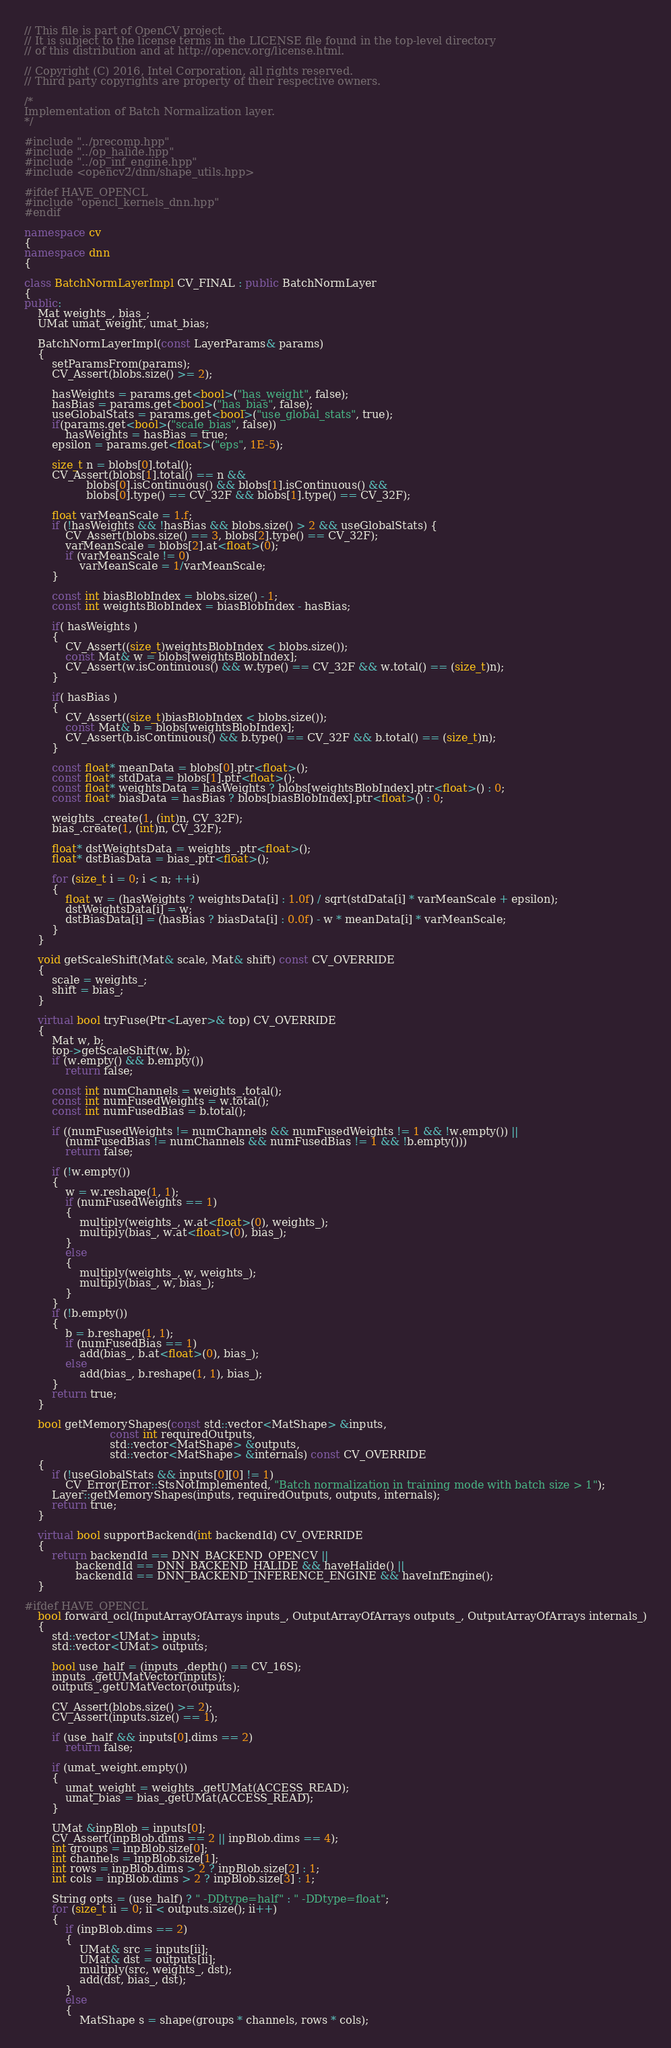Convert code to text. <code><loc_0><loc_0><loc_500><loc_500><_C++_>// This file is part of OpenCV project.
// It is subject to the license terms in the LICENSE file found in the top-level directory
// of this distribution and at http://opencv.org/license.html.

// Copyright (C) 2016, Intel Corporation, all rights reserved.
// Third party copyrights are property of their respective owners.

/*
Implementation of Batch Normalization layer.
*/

#include "../precomp.hpp"
#include "../op_halide.hpp"
#include "../op_inf_engine.hpp"
#include <opencv2/dnn/shape_utils.hpp>

#ifdef HAVE_OPENCL
#include "opencl_kernels_dnn.hpp"
#endif

namespace cv
{
namespace dnn
{

class BatchNormLayerImpl CV_FINAL : public BatchNormLayer
{
public:
    Mat weights_, bias_;
    UMat umat_weight, umat_bias;

    BatchNormLayerImpl(const LayerParams& params)
    {
        setParamsFrom(params);
        CV_Assert(blobs.size() >= 2);

        hasWeights = params.get<bool>("has_weight", false);
        hasBias = params.get<bool>("has_bias", false);
        useGlobalStats = params.get<bool>("use_global_stats", true);
        if(params.get<bool>("scale_bias", false))
            hasWeights = hasBias = true;
        epsilon = params.get<float>("eps", 1E-5);

        size_t n = blobs[0].total();
        CV_Assert(blobs[1].total() == n &&
                  blobs[0].isContinuous() && blobs[1].isContinuous() &&
                  blobs[0].type() == CV_32F && blobs[1].type() == CV_32F);

        float varMeanScale = 1.f;
        if (!hasWeights && !hasBias && blobs.size() > 2 && useGlobalStats) {
            CV_Assert(blobs.size() == 3, blobs[2].type() == CV_32F);
            varMeanScale = blobs[2].at<float>(0);
            if (varMeanScale != 0)
                varMeanScale = 1/varMeanScale;
        }

        const int biasBlobIndex = blobs.size() - 1;
        const int weightsBlobIndex = biasBlobIndex - hasBias;

        if( hasWeights )
        {
            CV_Assert((size_t)weightsBlobIndex < blobs.size());
            const Mat& w = blobs[weightsBlobIndex];
            CV_Assert(w.isContinuous() && w.type() == CV_32F && w.total() == (size_t)n);
        }

        if( hasBias )
        {
            CV_Assert((size_t)biasBlobIndex < blobs.size());
            const Mat& b = blobs[weightsBlobIndex];
            CV_Assert(b.isContinuous() && b.type() == CV_32F && b.total() == (size_t)n);
        }

        const float* meanData = blobs[0].ptr<float>();
        const float* stdData = blobs[1].ptr<float>();
        const float* weightsData = hasWeights ? blobs[weightsBlobIndex].ptr<float>() : 0;
        const float* biasData = hasBias ? blobs[biasBlobIndex].ptr<float>() : 0;

        weights_.create(1, (int)n, CV_32F);
        bias_.create(1, (int)n, CV_32F);

        float* dstWeightsData = weights_.ptr<float>();
        float* dstBiasData = bias_.ptr<float>();

        for (size_t i = 0; i < n; ++i)
        {
            float w = (hasWeights ? weightsData[i] : 1.0f) / sqrt(stdData[i] * varMeanScale + epsilon);
            dstWeightsData[i] = w;
            dstBiasData[i] = (hasBias ? biasData[i] : 0.0f) - w * meanData[i] * varMeanScale;
        }
    }

    void getScaleShift(Mat& scale, Mat& shift) const CV_OVERRIDE
    {
        scale = weights_;
        shift = bias_;
    }

    virtual bool tryFuse(Ptr<Layer>& top) CV_OVERRIDE
    {
        Mat w, b;
        top->getScaleShift(w, b);
        if (w.empty() && b.empty())
            return false;

        const int numChannels = weights_.total();
        const int numFusedWeights = w.total();
        const int numFusedBias = b.total();

        if ((numFusedWeights != numChannels && numFusedWeights != 1 && !w.empty()) ||
            (numFusedBias != numChannels && numFusedBias != 1 && !b.empty()))
            return false;

        if (!w.empty())
        {
            w = w.reshape(1, 1);
            if (numFusedWeights == 1)
            {
                multiply(weights_, w.at<float>(0), weights_);
                multiply(bias_, w.at<float>(0), bias_);
            }
            else
            {
                multiply(weights_, w, weights_);
                multiply(bias_, w, bias_);
            }
        }
        if (!b.empty())
        {
            b = b.reshape(1, 1);
            if (numFusedBias == 1)
                add(bias_, b.at<float>(0), bias_);
            else
                add(bias_, b.reshape(1, 1), bias_);
        }
        return true;
    }

    bool getMemoryShapes(const std::vector<MatShape> &inputs,
                         const int requiredOutputs,
                         std::vector<MatShape> &outputs,
                         std::vector<MatShape> &internals) const CV_OVERRIDE
    {
        if (!useGlobalStats && inputs[0][0] != 1)
            CV_Error(Error::StsNotImplemented, "Batch normalization in training mode with batch size > 1");
        Layer::getMemoryShapes(inputs, requiredOutputs, outputs, internals);
        return true;
    }

    virtual bool supportBackend(int backendId) CV_OVERRIDE
    {
        return backendId == DNN_BACKEND_OPENCV ||
               backendId == DNN_BACKEND_HALIDE && haveHalide() ||
               backendId == DNN_BACKEND_INFERENCE_ENGINE && haveInfEngine();
    }

#ifdef HAVE_OPENCL
    bool forward_ocl(InputArrayOfArrays inputs_, OutputArrayOfArrays outputs_, OutputArrayOfArrays internals_)
    {
        std::vector<UMat> inputs;
        std::vector<UMat> outputs;

        bool use_half = (inputs_.depth() == CV_16S);
        inputs_.getUMatVector(inputs);
        outputs_.getUMatVector(outputs);

        CV_Assert(blobs.size() >= 2);
        CV_Assert(inputs.size() == 1);

        if (use_half && inputs[0].dims == 2)
            return false;

        if (umat_weight.empty())
        {
            umat_weight = weights_.getUMat(ACCESS_READ);
            umat_bias = bias_.getUMat(ACCESS_READ);
        }

        UMat &inpBlob = inputs[0];
        CV_Assert(inpBlob.dims == 2 || inpBlob.dims == 4);
        int groups = inpBlob.size[0];
        int channels = inpBlob.size[1];
        int rows = inpBlob.dims > 2 ? inpBlob.size[2] : 1;
        int cols = inpBlob.dims > 2 ? inpBlob.size[3] : 1;

        String opts = (use_half) ? " -DDtype=half" : " -DDtype=float";
        for (size_t ii = 0; ii < outputs.size(); ii++)
        {
            if (inpBlob.dims == 2)
            {
                UMat& src = inputs[ii];
                UMat& dst = outputs[ii];
                multiply(src, weights_, dst);
                add(dst, bias_, dst);
            }
            else
            {
                MatShape s = shape(groups * channels, rows * cols);</code> 